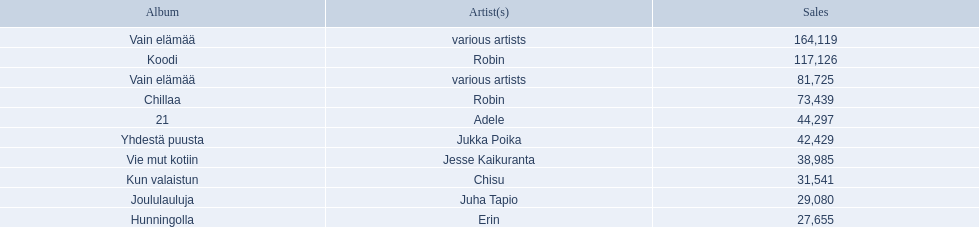Which albums had number-one albums in finland in 2012? 1, Vain elämää, Koodi, Vain elämää, Chillaa, 21, Yhdestä puusta, Vie mut kotiin, Kun valaistun, Joululauluja, Hunningolla. Of those albums, which were recorded by only one artist? Koodi, Chillaa, 21, Yhdestä puusta, Vie mut kotiin, Kun valaistun, Joululauluja, Hunningolla. Which albums made between 30,000 and 45,000 in sales? 21, Yhdestä puusta, Vie mut kotiin, Kun valaistun. Of those albums which had the highest sales? 21. Who was the artist for that album? Adele. What sales does adele have? 44,297. What sales does chisu have? 31,541. Which of these numbers are higher? 44,297. Who has this number of sales? Adele. 